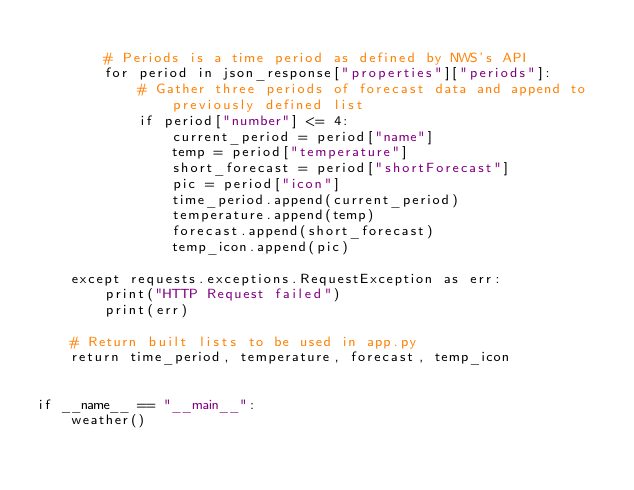Convert code to text. <code><loc_0><loc_0><loc_500><loc_500><_Python_>
        # Periods is a time period as defined by NWS's API
        for period in json_response["properties"]["periods"]:
            # Gather three periods of forecast data and append to previously defined list
            if period["number"] <= 4:
                current_period = period["name"]
                temp = period["temperature"]
                short_forecast = period["shortForecast"]
                pic = period["icon"]
                time_period.append(current_period)
                temperature.append(temp)
                forecast.append(short_forecast)
                temp_icon.append(pic)

    except requests.exceptions.RequestException as err:
        print("HTTP Request failed")
        print(err)

    # Return built lists to be used in app.py
    return time_period, temperature, forecast, temp_icon


if __name__ == "__main__":
    weather()
</code> 